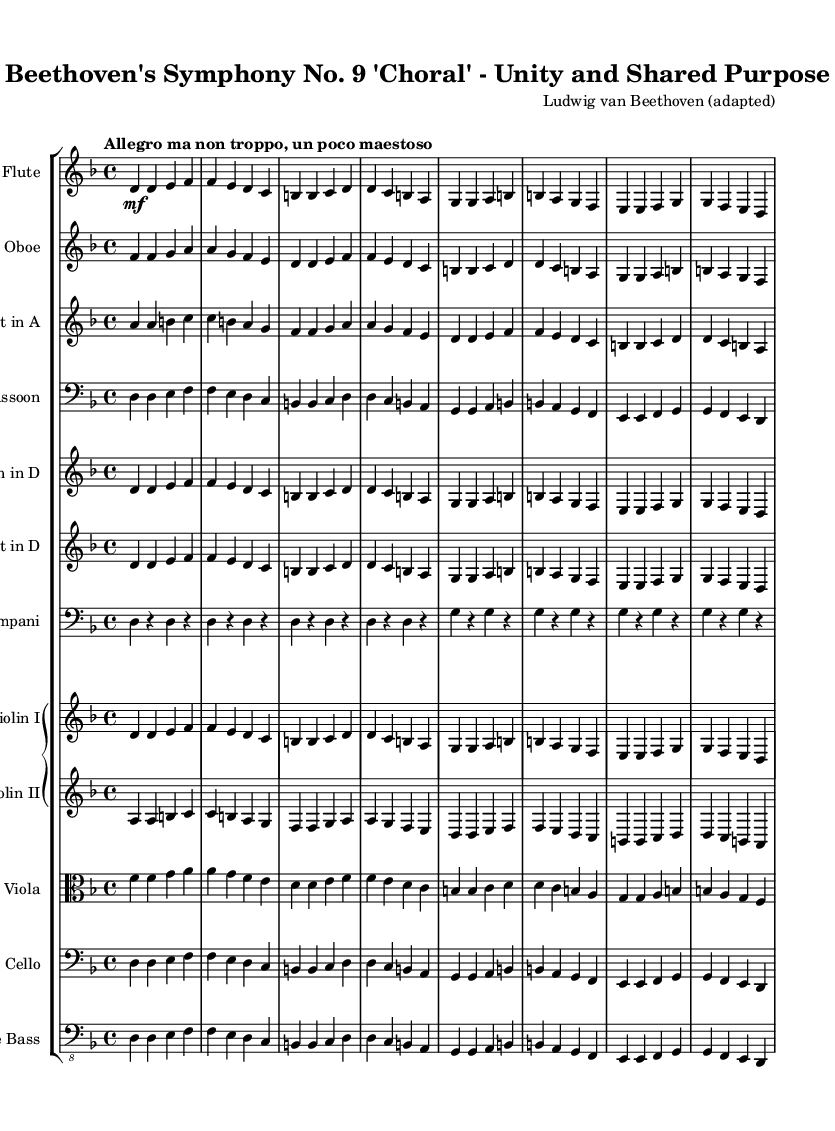What is the key signature of this music? The key signature is indicated at the beginning of the score, showing one flat, which corresponds to D minor.
Answer: D minor What is the time signature of this piece? The time signature is found at the start of the score, which is 4/4, indicating four beats per measure.
Answer: 4/4 What is the tempo marking for this symphony? The tempo marking appears at the beginning following the time signature, stating "Allegro ma non troppo, un poco maestoso," describing the desired speed and character.
Answer: Allegro ma non troppo, un poco maestoso How many instruments are indicated in the score? By counting the distinct staves present in the score, there are a total of twelve instruments represented.
Answer: Twelve Which instrument plays the lowest notes? The instrument playing the lowest notes is the Double Bass, identified by its clef and staff position in the score.
Answer: Double Bass How do the melody lines in Violin I and Violin II differ? To find the differences, compare the relative pitches and rhythmic patterns in the Violin I and Violin II staves; Violin II generally plays higher adjacent pitches in a different range than Violin I.
Answer: Violin II plays higher pitches What type of musical composition is represented by this score? The header indicates that this is a Symphony, specifically Beethoven's Symphony No. 9, which includes choral elements, commonly known for its themes of unity.
Answer: Symphony 